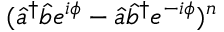<formula> <loc_0><loc_0><loc_500><loc_500>( \hat { a } ^ { \dag } \hat { b } e ^ { i \phi } - \hat { a } \hat { b } ^ { \dag } e ^ { - i \phi } ) ^ { n }</formula> 